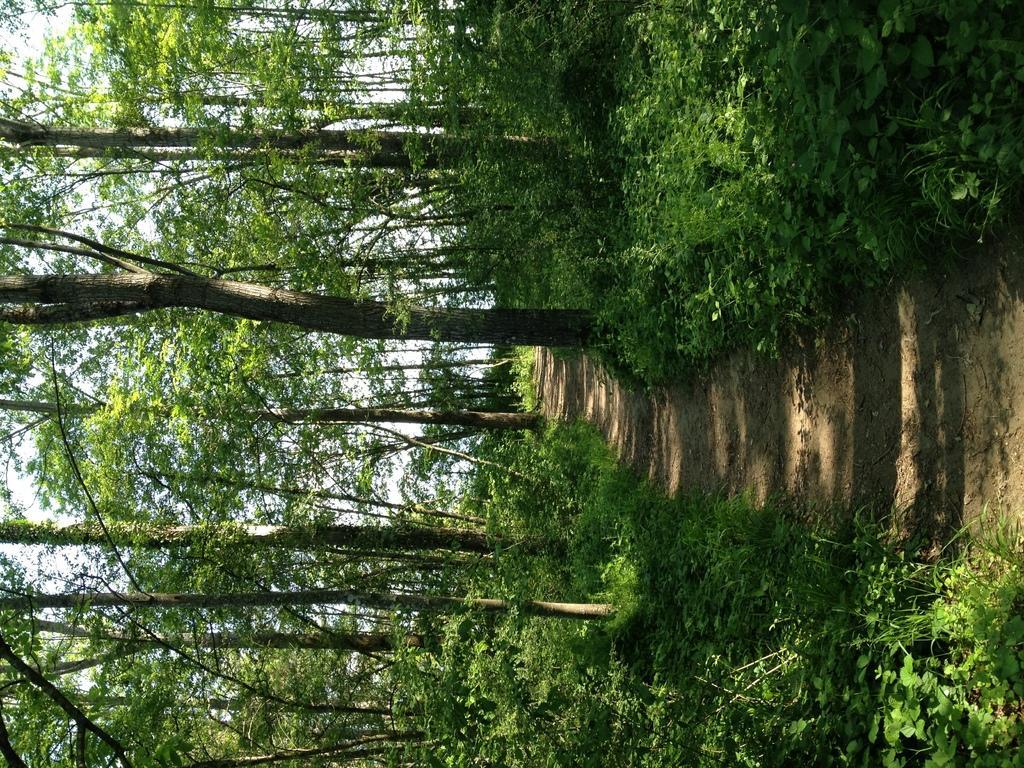Describe this image in one or two sentences. This image is in left direction. On the right side there is a path. On both sides of it there are many plants and trees. In the background, I can see the sky. 